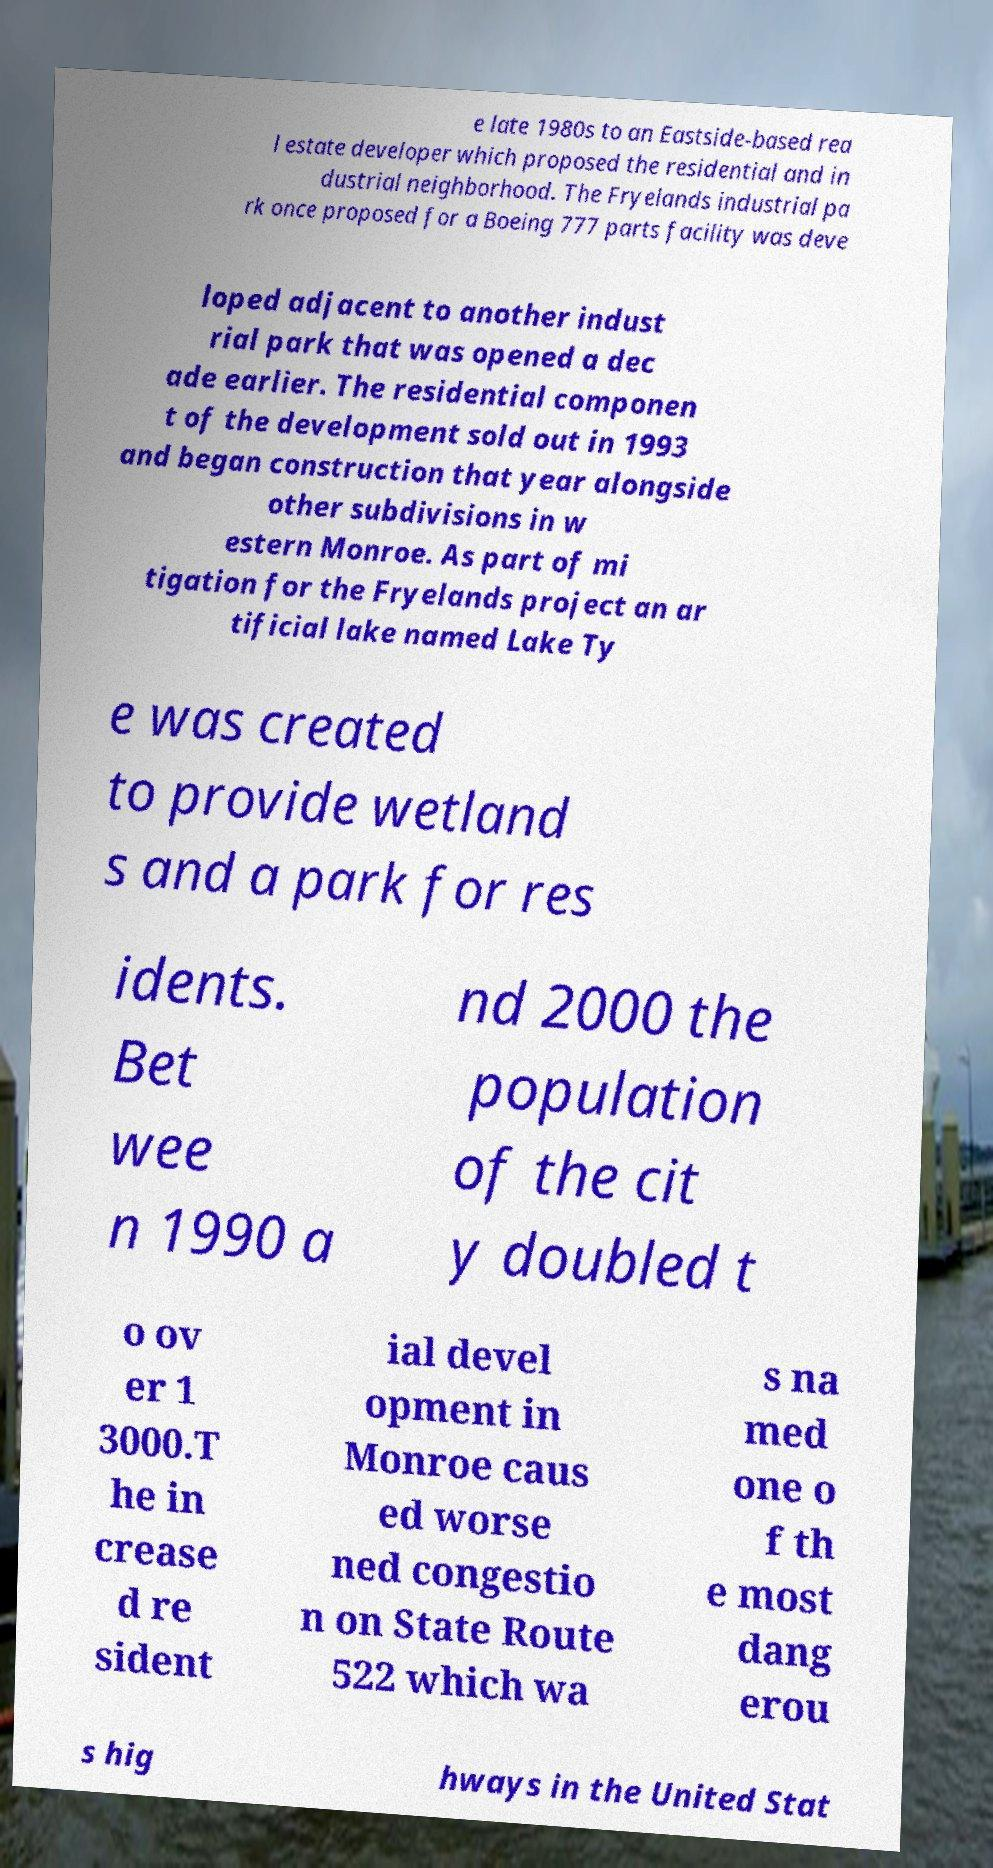Could you extract and type out the text from this image? e late 1980s to an Eastside-based rea l estate developer which proposed the residential and in dustrial neighborhood. The Fryelands industrial pa rk once proposed for a Boeing 777 parts facility was deve loped adjacent to another indust rial park that was opened a dec ade earlier. The residential componen t of the development sold out in 1993 and began construction that year alongside other subdivisions in w estern Monroe. As part of mi tigation for the Fryelands project an ar tificial lake named Lake Ty e was created to provide wetland s and a park for res idents. Bet wee n 1990 a nd 2000 the population of the cit y doubled t o ov er 1 3000.T he in crease d re sident ial devel opment in Monroe caus ed worse ned congestio n on State Route 522 which wa s na med one o f th e most dang erou s hig hways in the United Stat 